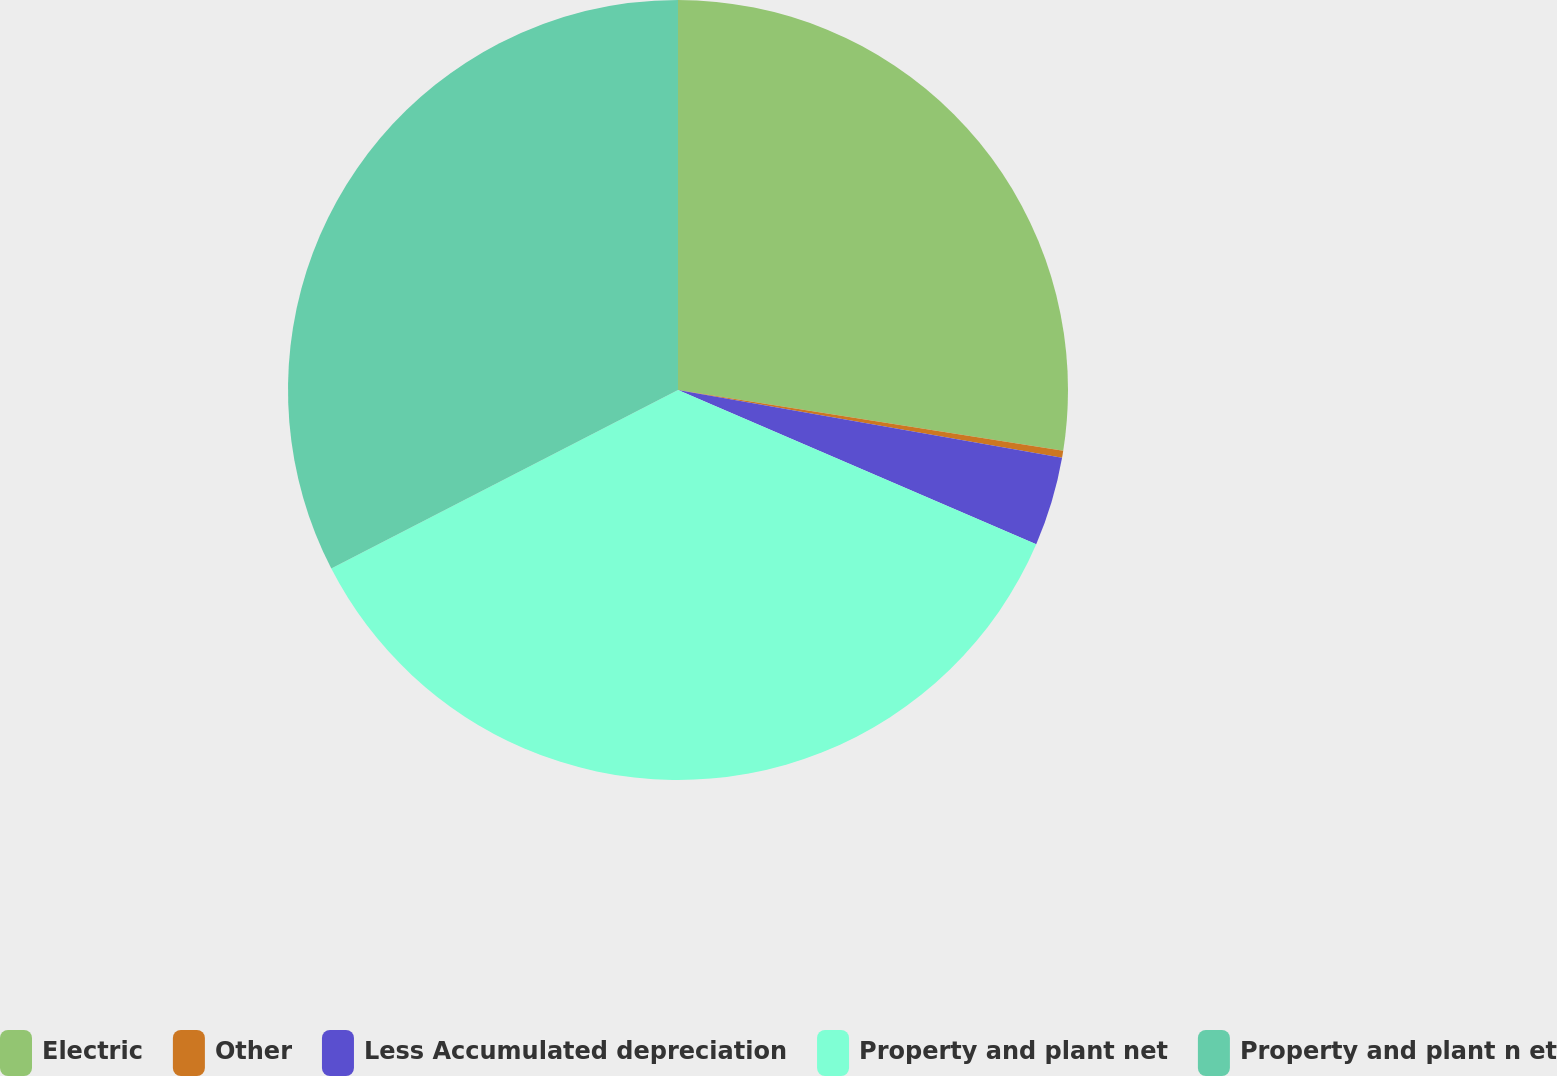Convert chart. <chart><loc_0><loc_0><loc_500><loc_500><pie_chart><fcel>Electric<fcel>Other<fcel>Less Accumulated depreciation<fcel>Property and plant net<fcel>Property and plant n et<nl><fcel>27.49%<fcel>0.29%<fcel>3.69%<fcel>35.96%<fcel>32.57%<nl></chart> 